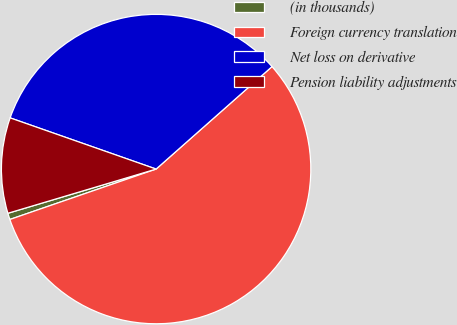Convert chart. <chart><loc_0><loc_0><loc_500><loc_500><pie_chart><fcel>(in thousands)<fcel>Foreign currency translation<fcel>Net loss on derivative<fcel>Pension liability adjustments<nl><fcel>0.67%<fcel>56.24%<fcel>33.11%<fcel>9.98%<nl></chart> 